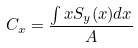<formula> <loc_0><loc_0><loc_500><loc_500>C _ { x } = \frac { \int x S _ { y } ( x ) d x } { A }</formula> 